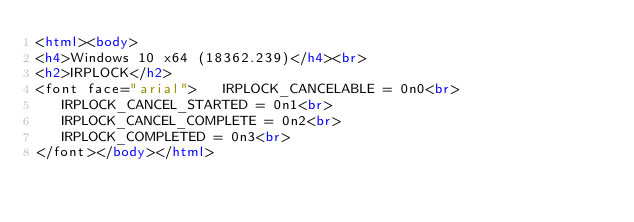Convert code to text. <code><loc_0><loc_0><loc_500><loc_500><_HTML_><html><body>
<h4>Windows 10 x64 (18362.239)</h4><br>
<h2>IRPLOCK</h2>
<font face="arial">   IRPLOCK_CANCELABLE = 0n0<br>
   IRPLOCK_CANCEL_STARTED = 0n1<br>
   IRPLOCK_CANCEL_COMPLETE = 0n2<br>
   IRPLOCK_COMPLETED = 0n3<br>
</font></body></html></code> 